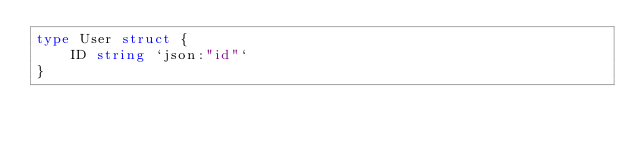Convert code to text. <code><loc_0><loc_0><loc_500><loc_500><_Go_>type User struct {
	ID string `json:"id"`
}
</code> 